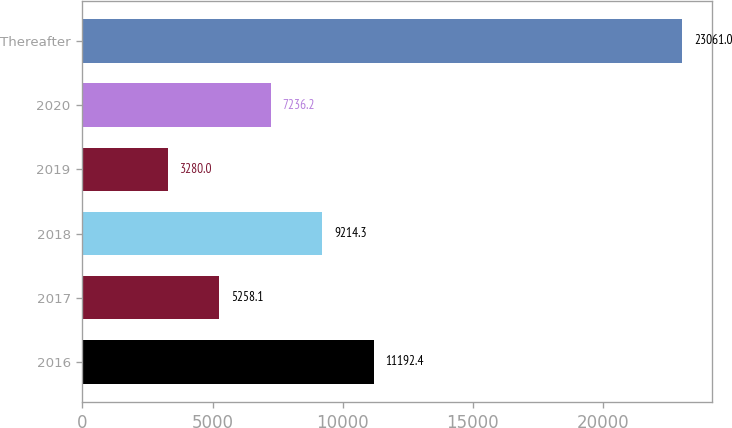Convert chart to OTSL. <chart><loc_0><loc_0><loc_500><loc_500><bar_chart><fcel>2016<fcel>2017<fcel>2018<fcel>2019<fcel>2020<fcel>Thereafter<nl><fcel>11192.4<fcel>5258.1<fcel>9214.3<fcel>3280<fcel>7236.2<fcel>23061<nl></chart> 